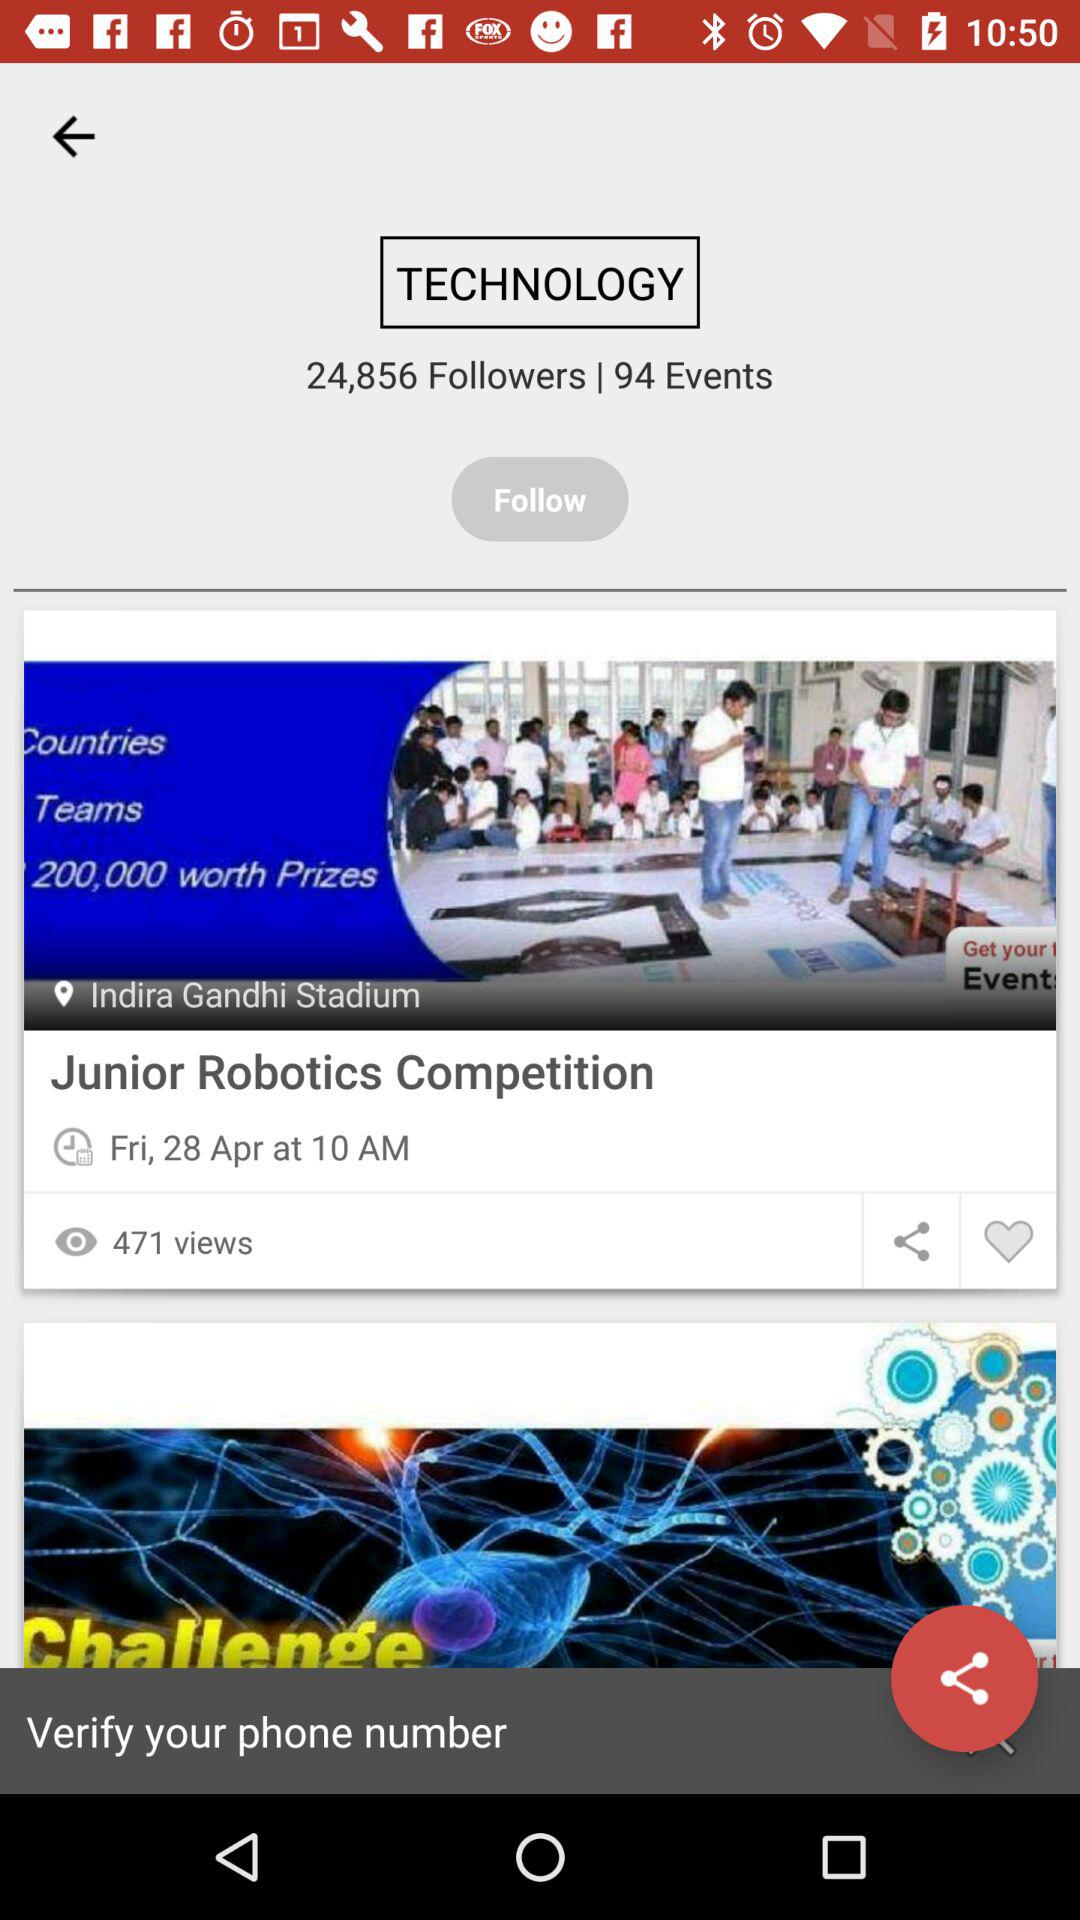What is the time for the "Junior Robotics Competition"? The time for the "Junior Robotics Competition" is 10 a.m. 